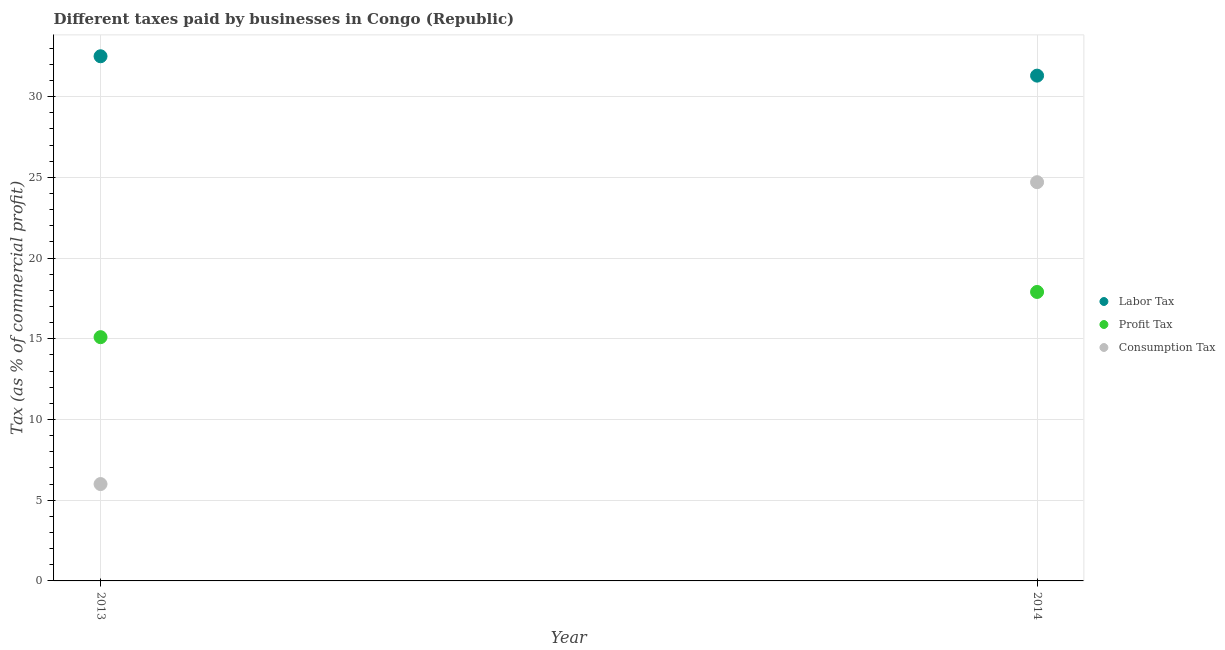How many different coloured dotlines are there?
Your answer should be very brief. 3. Is the number of dotlines equal to the number of legend labels?
Provide a succinct answer. Yes. What is the percentage of profit tax in 2014?
Your answer should be compact. 17.9. In which year was the percentage of labor tax maximum?
Offer a terse response. 2013. What is the difference between the percentage of consumption tax in 2013 and that in 2014?
Ensure brevity in your answer.  -18.7. What is the difference between the percentage of labor tax in 2014 and the percentage of consumption tax in 2013?
Your answer should be very brief. 25.3. What is the average percentage of profit tax per year?
Your answer should be very brief. 16.5. In the year 2013, what is the difference between the percentage of consumption tax and percentage of labor tax?
Keep it short and to the point. -26.5. What is the ratio of the percentage of consumption tax in 2013 to that in 2014?
Provide a succinct answer. 0.24. Is it the case that in every year, the sum of the percentage of labor tax and percentage of profit tax is greater than the percentage of consumption tax?
Offer a very short reply. Yes. Does the percentage of profit tax monotonically increase over the years?
Provide a succinct answer. Yes. Is the percentage of consumption tax strictly less than the percentage of profit tax over the years?
Provide a succinct answer. No. How many years are there in the graph?
Give a very brief answer. 2. What is the difference between two consecutive major ticks on the Y-axis?
Your answer should be very brief. 5. Does the graph contain any zero values?
Give a very brief answer. No. Where does the legend appear in the graph?
Offer a very short reply. Center right. What is the title of the graph?
Keep it short and to the point. Different taxes paid by businesses in Congo (Republic). What is the label or title of the Y-axis?
Provide a short and direct response. Tax (as % of commercial profit). What is the Tax (as % of commercial profit) of Labor Tax in 2013?
Your response must be concise. 32.5. What is the Tax (as % of commercial profit) in Profit Tax in 2013?
Give a very brief answer. 15.1. What is the Tax (as % of commercial profit) of Consumption Tax in 2013?
Ensure brevity in your answer.  6. What is the Tax (as % of commercial profit) in Labor Tax in 2014?
Your answer should be very brief. 31.3. What is the Tax (as % of commercial profit) in Profit Tax in 2014?
Keep it short and to the point. 17.9. What is the Tax (as % of commercial profit) in Consumption Tax in 2014?
Give a very brief answer. 24.7. Across all years, what is the maximum Tax (as % of commercial profit) in Labor Tax?
Keep it short and to the point. 32.5. Across all years, what is the maximum Tax (as % of commercial profit) of Consumption Tax?
Offer a terse response. 24.7. Across all years, what is the minimum Tax (as % of commercial profit) in Labor Tax?
Provide a succinct answer. 31.3. What is the total Tax (as % of commercial profit) of Labor Tax in the graph?
Offer a very short reply. 63.8. What is the total Tax (as % of commercial profit) in Consumption Tax in the graph?
Your answer should be compact. 30.7. What is the difference between the Tax (as % of commercial profit) in Labor Tax in 2013 and that in 2014?
Give a very brief answer. 1.2. What is the difference between the Tax (as % of commercial profit) of Profit Tax in 2013 and that in 2014?
Your answer should be compact. -2.8. What is the difference between the Tax (as % of commercial profit) in Consumption Tax in 2013 and that in 2014?
Your response must be concise. -18.7. What is the difference between the Tax (as % of commercial profit) in Labor Tax in 2013 and the Tax (as % of commercial profit) in Profit Tax in 2014?
Provide a short and direct response. 14.6. What is the difference between the Tax (as % of commercial profit) of Profit Tax in 2013 and the Tax (as % of commercial profit) of Consumption Tax in 2014?
Offer a terse response. -9.6. What is the average Tax (as % of commercial profit) in Labor Tax per year?
Make the answer very short. 31.9. What is the average Tax (as % of commercial profit) of Consumption Tax per year?
Your response must be concise. 15.35. In the year 2013, what is the difference between the Tax (as % of commercial profit) of Labor Tax and Tax (as % of commercial profit) of Profit Tax?
Your answer should be compact. 17.4. In the year 2013, what is the difference between the Tax (as % of commercial profit) of Labor Tax and Tax (as % of commercial profit) of Consumption Tax?
Keep it short and to the point. 26.5. In the year 2014, what is the difference between the Tax (as % of commercial profit) of Labor Tax and Tax (as % of commercial profit) of Profit Tax?
Make the answer very short. 13.4. What is the ratio of the Tax (as % of commercial profit) in Labor Tax in 2013 to that in 2014?
Keep it short and to the point. 1.04. What is the ratio of the Tax (as % of commercial profit) in Profit Tax in 2013 to that in 2014?
Make the answer very short. 0.84. What is the ratio of the Tax (as % of commercial profit) in Consumption Tax in 2013 to that in 2014?
Make the answer very short. 0.24. What is the difference between the highest and the second highest Tax (as % of commercial profit) of Labor Tax?
Your answer should be very brief. 1.2. What is the difference between the highest and the lowest Tax (as % of commercial profit) of Profit Tax?
Make the answer very short. 2.8. What is the difference between the highest and the lowest Tax (as % of commercial profit) in Consumption Tax?
Ensure brevity in your answer.  18.7. 